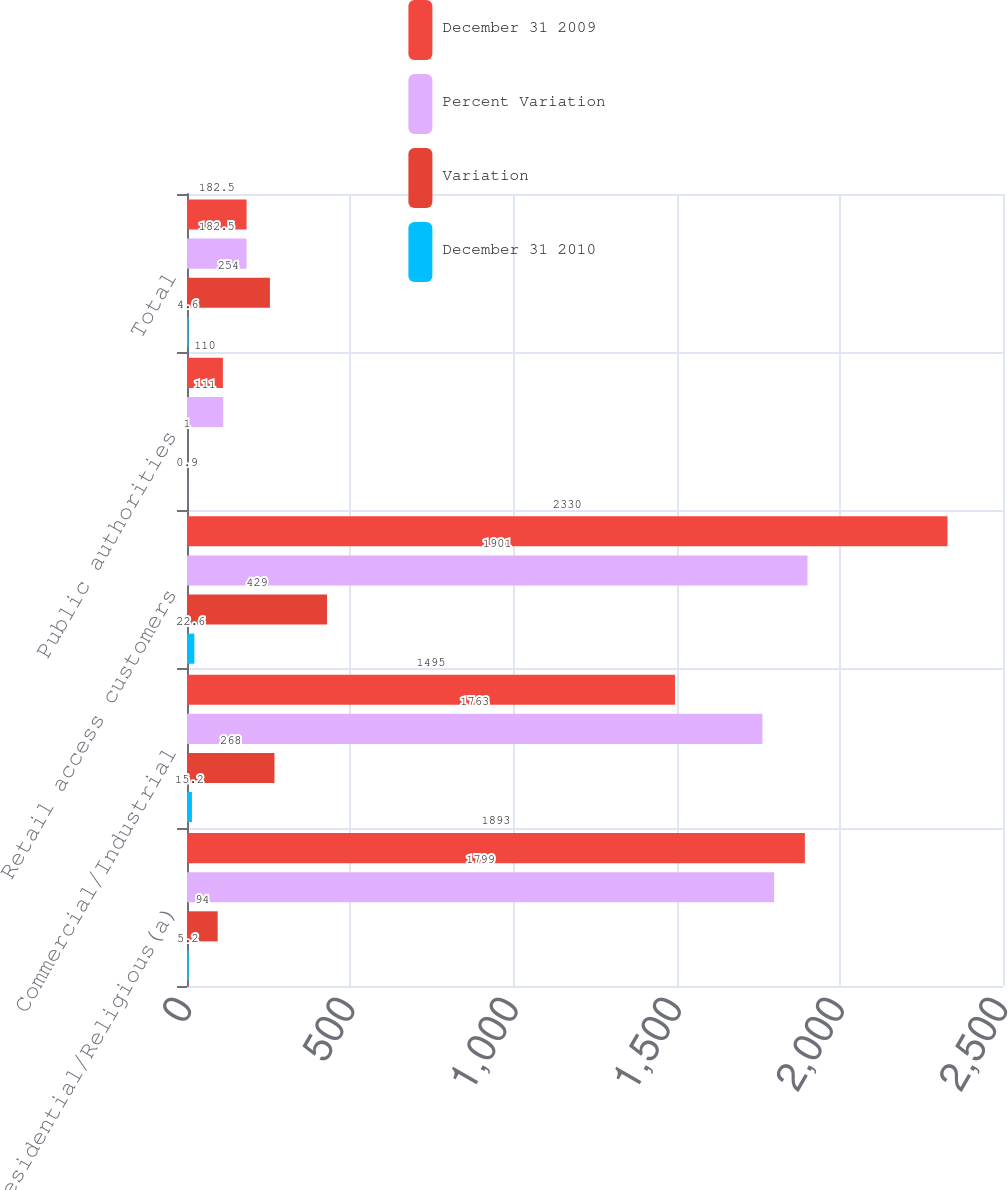<chart> <loc_0><loc_0><loc_500><loc_500><stacked_bar_chart><ecel><fcel>Residential/Religious(a)<fcel>Commercial/Industrial<fcel>Retail access customers<fcel>Public authorities<fcel>Total<nl><fcel>December 31 2009<fcel>1893<fcel>1495<fcel>2330<fcel>110<fcel>182.5<nl><fcel>Percent Variation<fcel>1799<fcel>1763<fcel>1901<fcel>111<fcel>182.5<nl><fcel>Variation<fcel>94<fcel>268<fcel>429<fcel>1<fcel>254<nl><fcel>December 31 2010<fcel>5.2<fcel>15.2<fcel>22.6<fcel>0.9<fcel>4.6<nl></chart> 